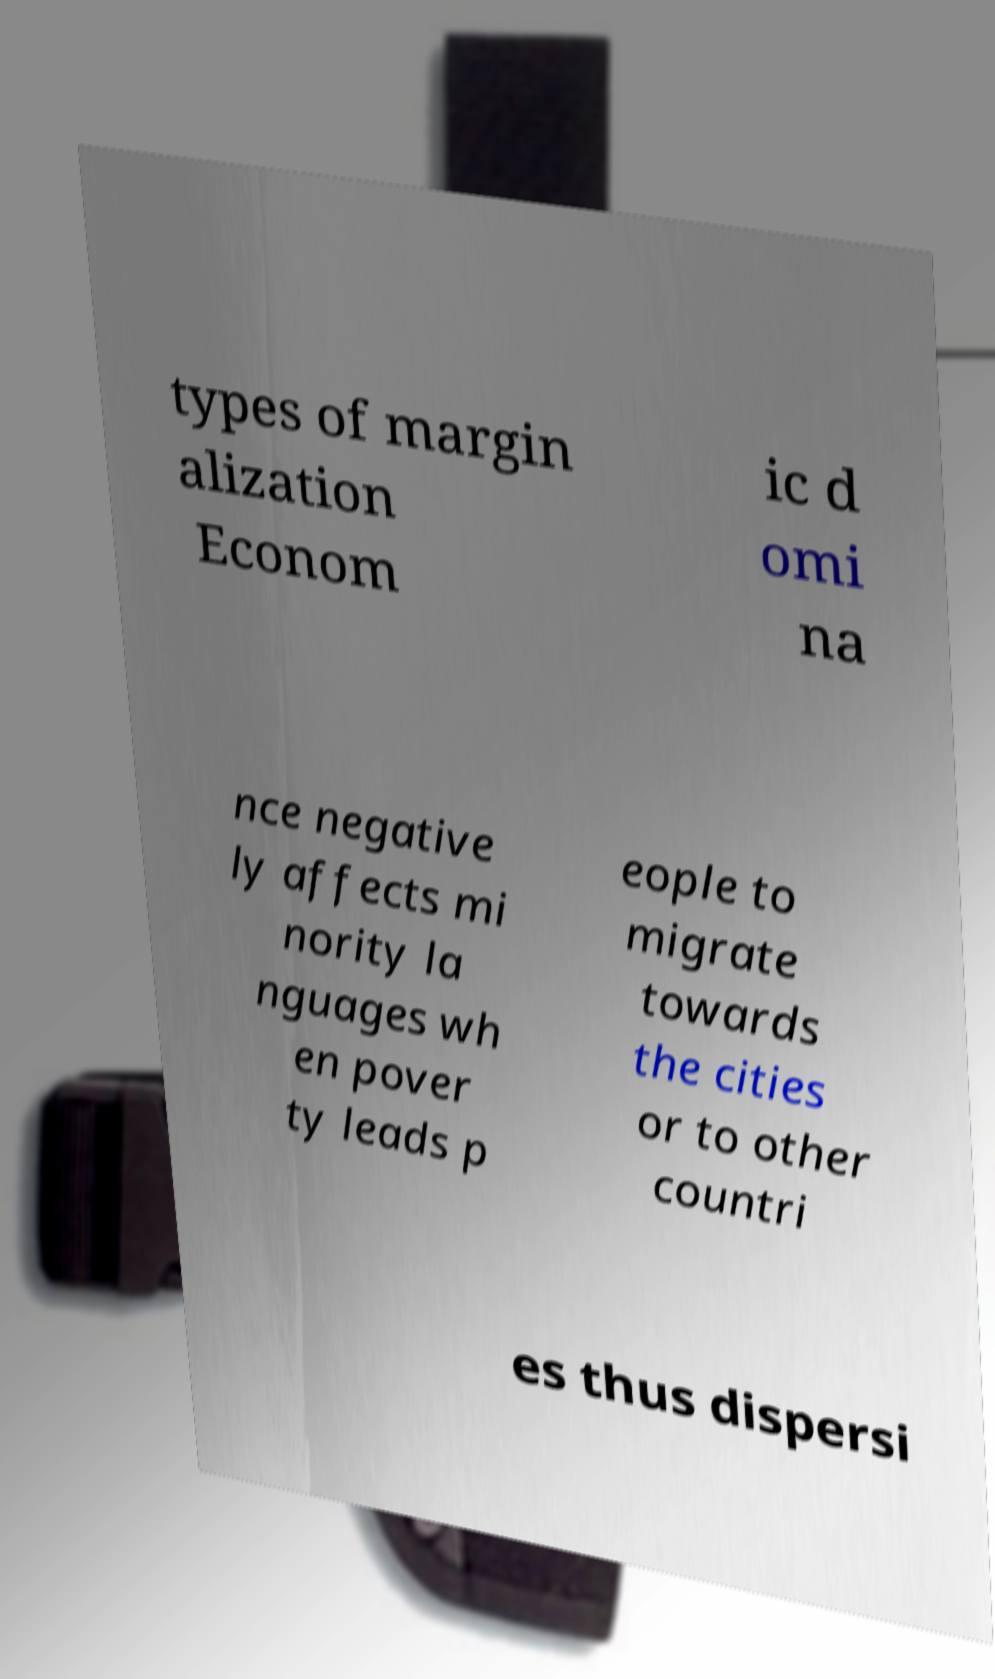There's text embedded in this image that I need extracted. Can you transcribe it verbatim? types of margin alization Econom ic d omi na nce negative ly affects mi nority la nguages wh en pover ty leads p eople to migrate towards the cities or to other countri es thus dispersi 